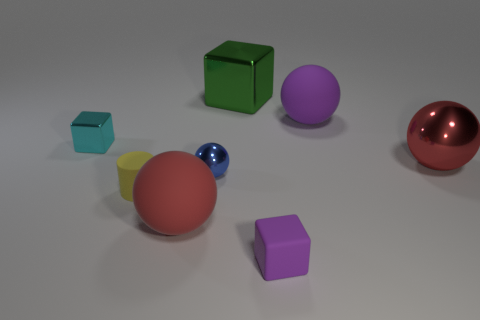How many other objects are the same color as the small matte block?
Provide a short and direct response. 1. There is a big thing that is in front of the small blue metallic object that is on the left side of the small purple rubber cube; what is it made of?
Ensure brevity in your answer.  Rubber. Is the number of big red things behind the tiny yellow thing the same as the number of metal things that are to the left of the cyan metal block?
Offer a very short reply. No. Does the small cyan metal thing have the same shape as the yellow object?
Your answer should be very brief. No. There is a thing that is both in front of the red metal object and behind the yellow rubber object; what material is it?
Provide a succinct answer. Metal. How many large green shiny objects are the same shape as the cyan object?
Your answer should be very brief. 1. There is a shiny ball that is in front of the red ball that is on the right side of the cube that is behind the cyan shiny cube; how big is it?
Give a very brief answer. Small. Is the number of tiny purple matte objects that are in front of the cylinder greater than the number of matte cylinders?
Offer a very short reply. No. Is there a cyan rubber cylinder?
Keep it short and to the point. No. How many shiny spheres are the same size as the red matte thing?
Ensure brevity in your answer.  1. 